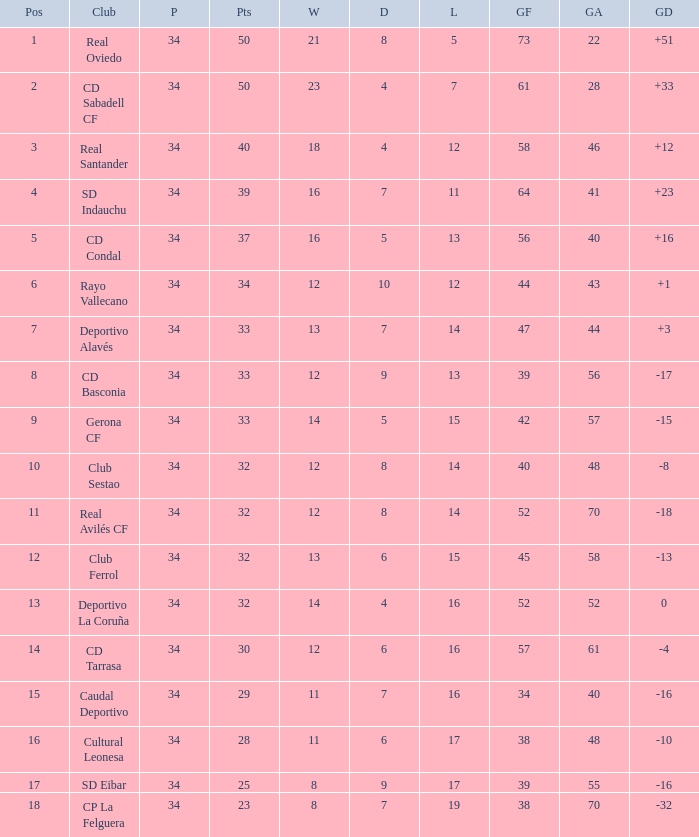Which Losses have a Goal Difference of -16, and less than 8 wins? None. 